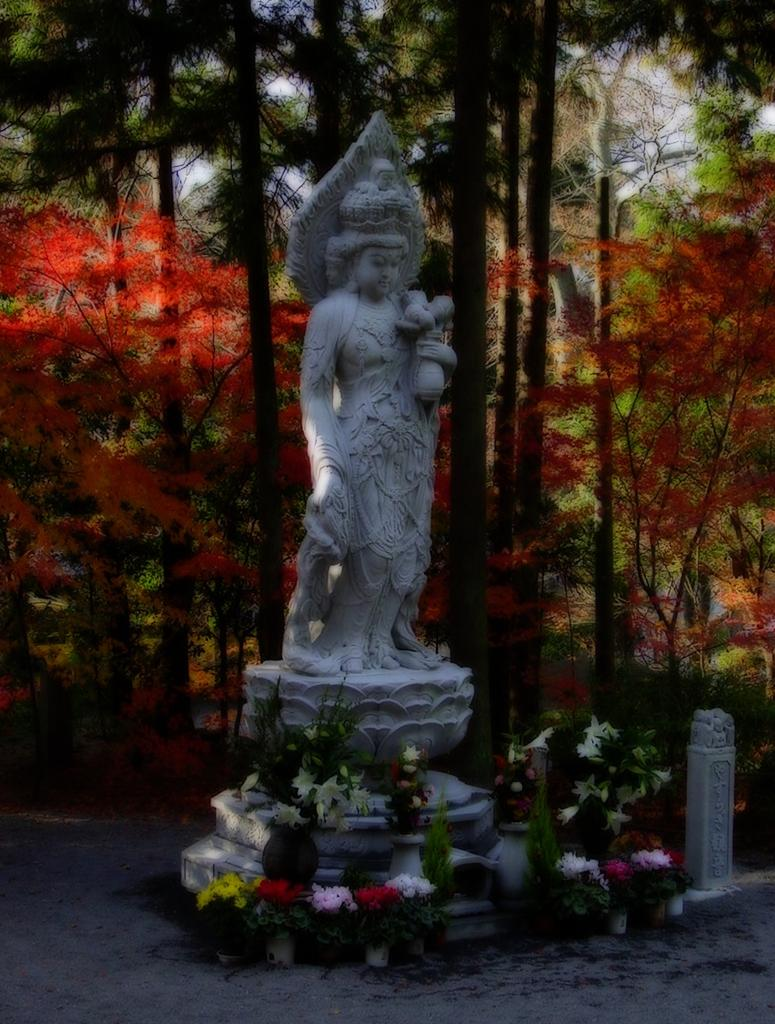What is the main subject in the image? There is a sculpture in the image. What can be seen in the background of the image? There are trees visible in the background of the image. What objects are on the ground in the image? There are flower pots on the ground in the image. Is the sculpture wearing a cap in the image? There is no cap visible on the sculpture in the image. Can you see any quicksand in the image? There is no quicksand present in the image. 